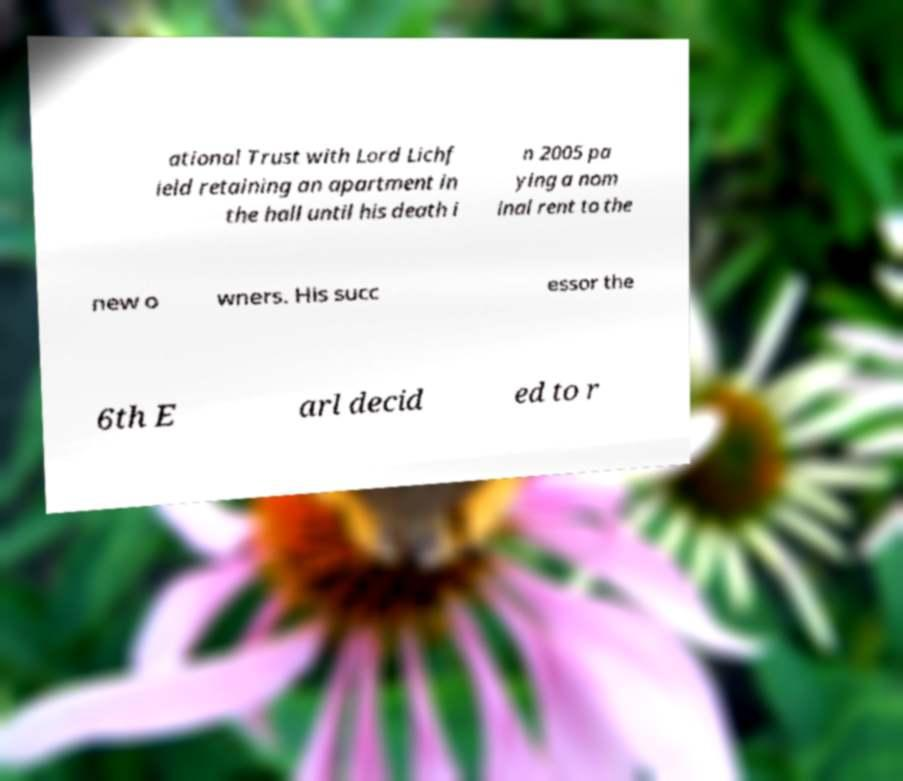Please identify and transcribe the text found in this image. ational Trust with Lord Lichf ield retaining an apartment in the hall until his death i n 2005 pa ying a nom inal rent to the new o wners. His succ essor the 6th E arl decid ed to r 